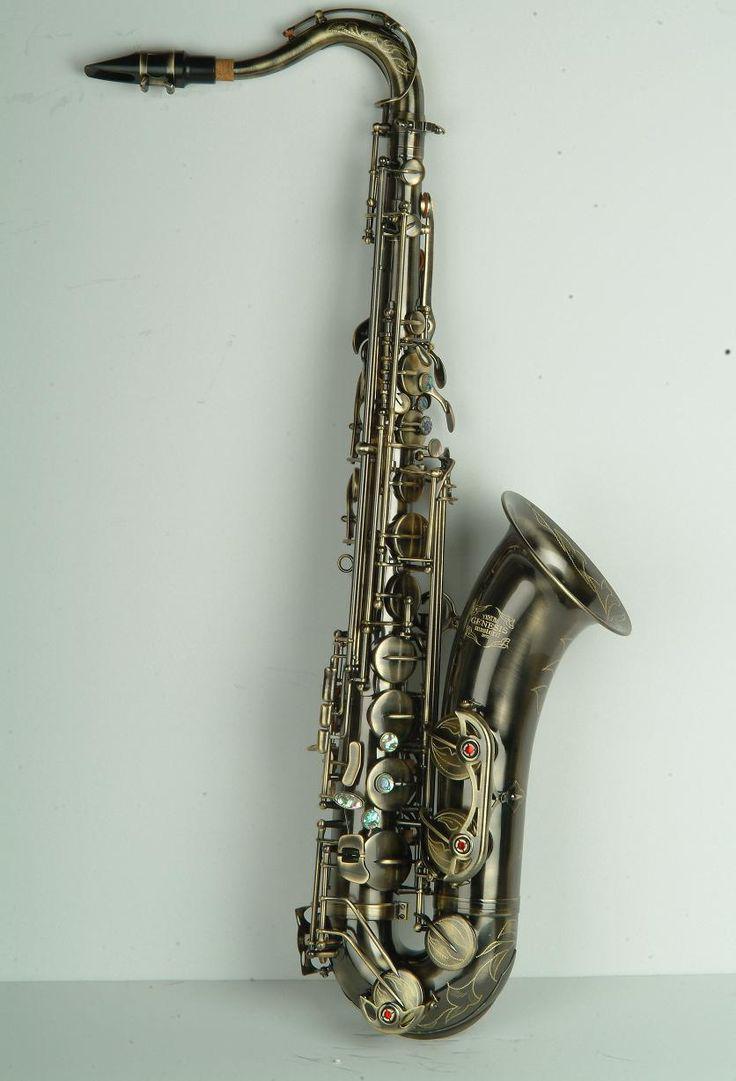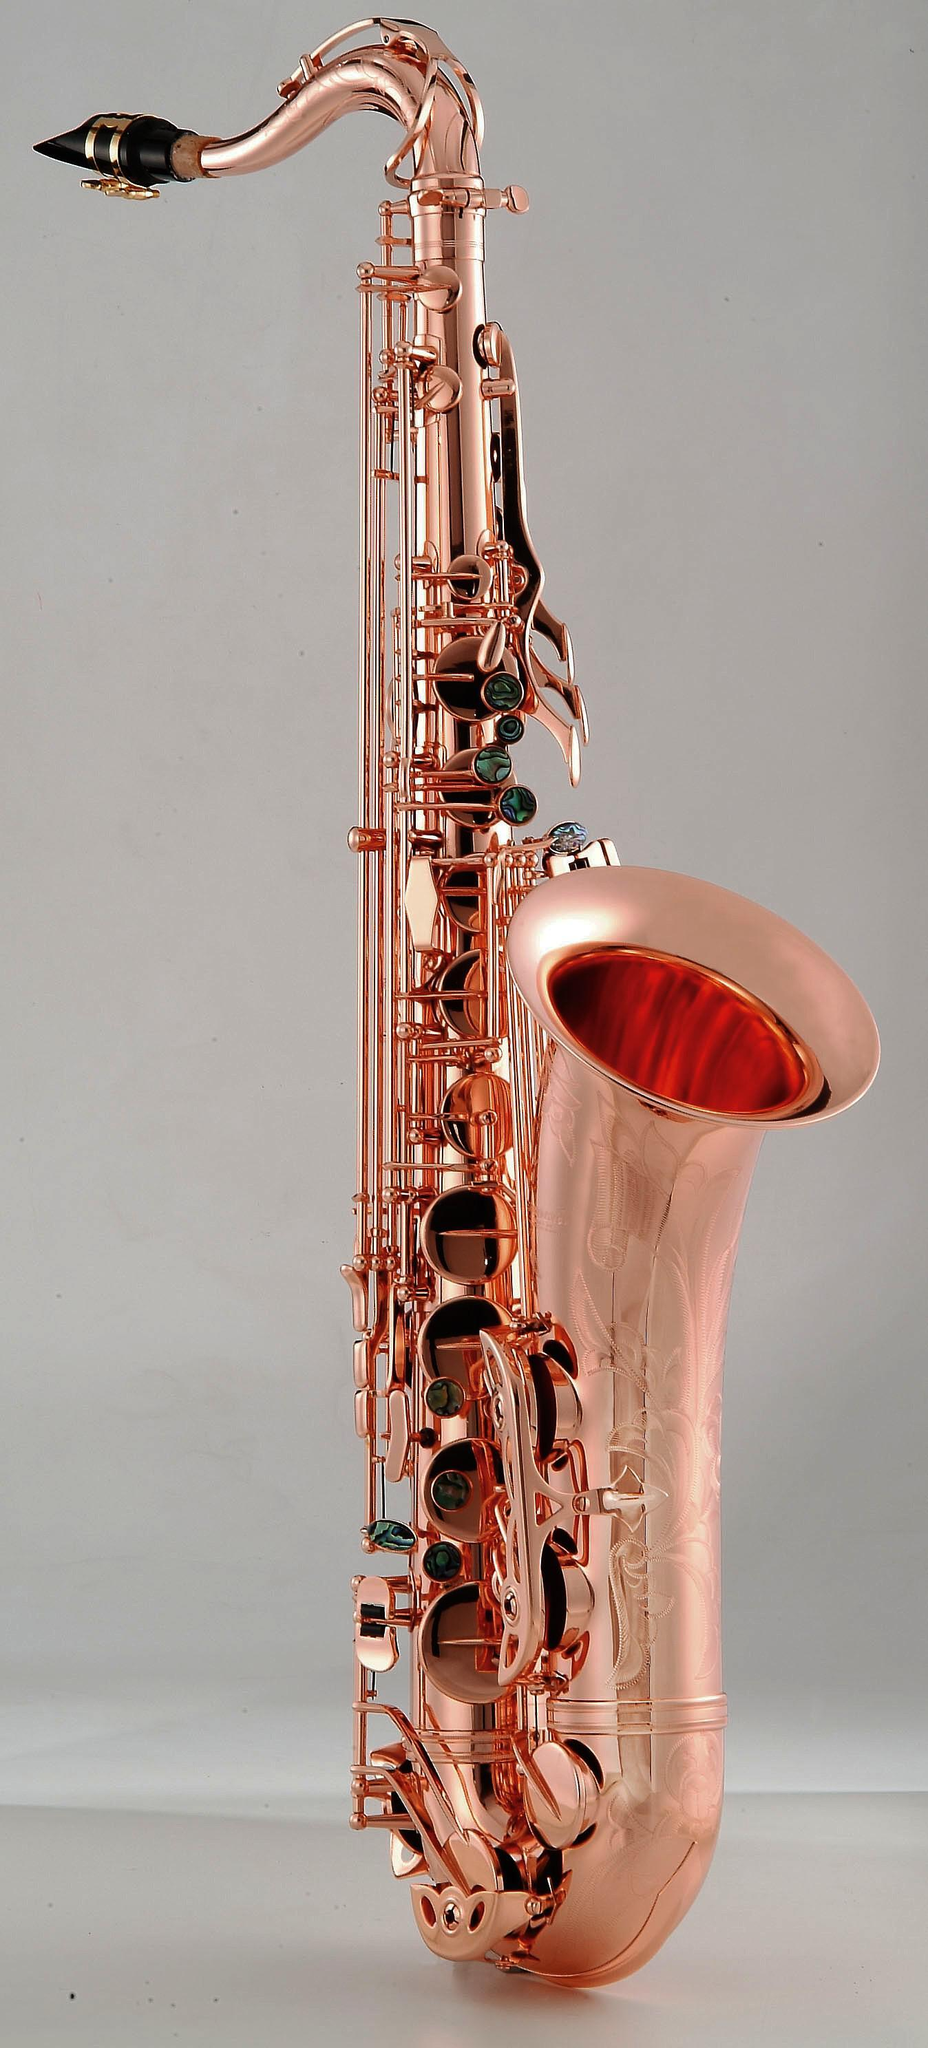The first image is the image on the left, the second image is the image on the right. For the images shown, is this caption "At least one saxophone is not a traditional metal color." true? Answer yes or no. No. The first image is the image on the left, the second image is the image on the right. Assess this claim about the two images: "Both of the saxophones are set up in the same position.". Correct or not? Answer yes or no. Yes. 